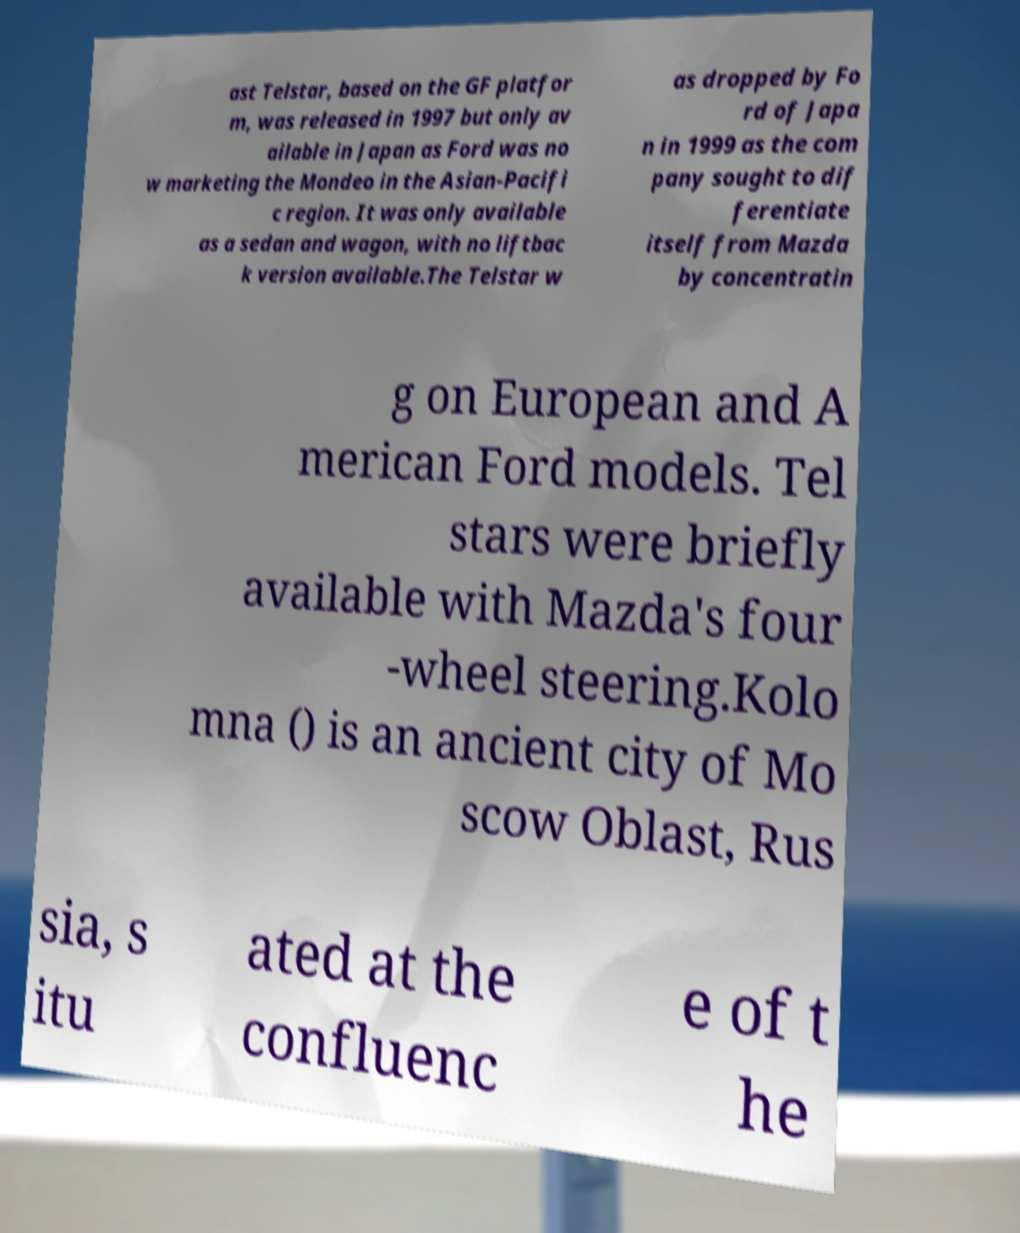Could you assist in decoding the text presented in this image and type it out clearly? ast Telstar, based on the GF platfor m, was released in 1997 but only av ailable in Japan as Ford was no w marketing the Mondeo in the Asian-Pacifi c region. It was only available as a sedan and wagon, with no liftbac k version available.The Telstar w as dropped by Fo rd of Japa n in 1999 as the com pany sought to dif ferentiate itself from Mazda by concentratin g on European and A merican Ford models. Tel stars were briefly available with Mazda's four -wheel steering.Kolo mna () is an ancient city of Mo scow Oblast, Rus sia, s itu ated at the confluenc e of t he 